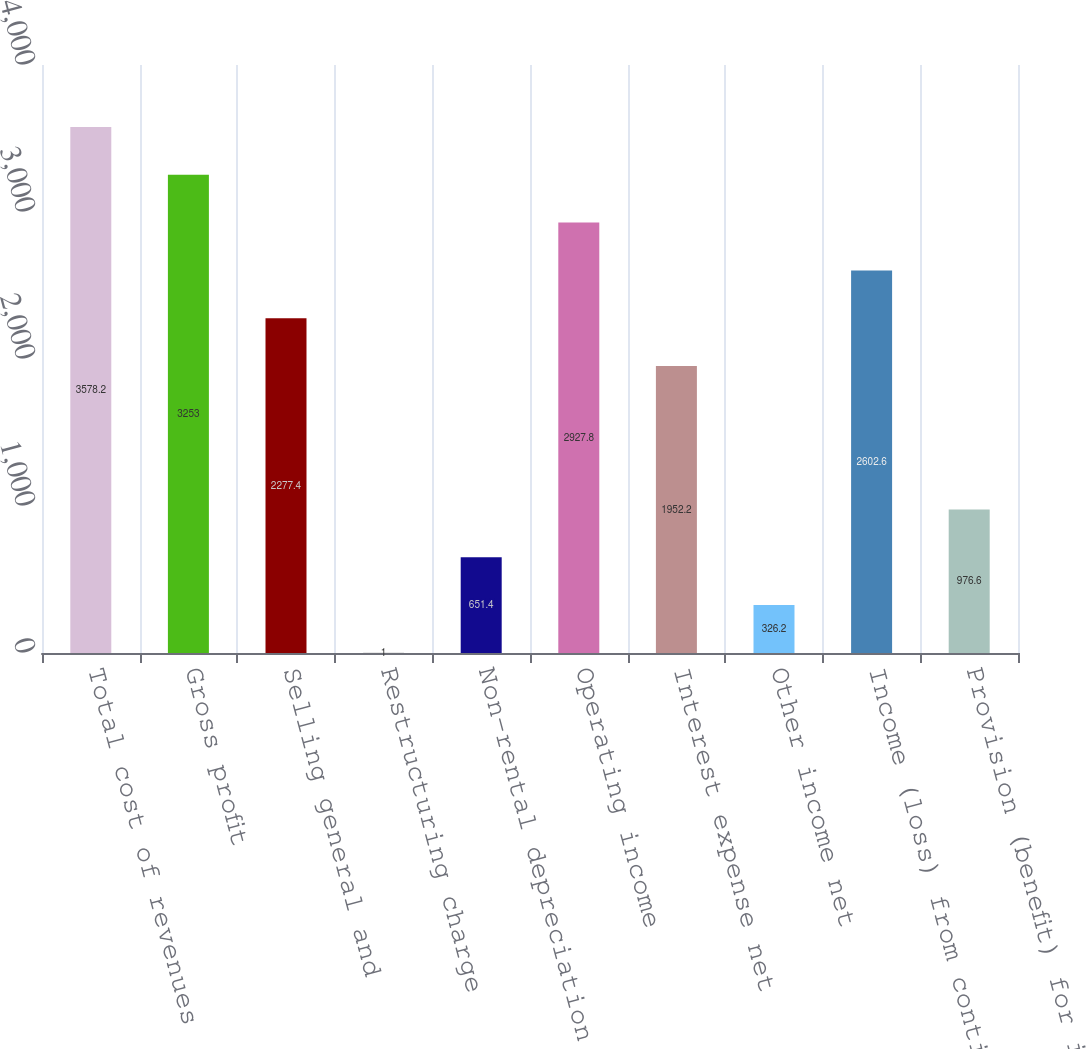<chart> <loc_0><loc_0><loc_500><loc_500><bar_chart><fcel>Total cost of revenues<fcel>Gross profit<fcel>Selling general and<fcel>Restructuring charge<fcel>Non-rental depreciation and<fcel>Operating income<fcel>Interest expense net<fcel>Other income net<fcel>Income (loss) from continuing<fcel>Provision (benefit) for income<nl><fcel>3578.2<fcel>3253<fcel>2277.4<fcel>1<fcel>651.4<fcel>2927.8<fcel>1952.2<fcel>326.2<fcel>2602.6<fcel>976.6<nl></chart> 